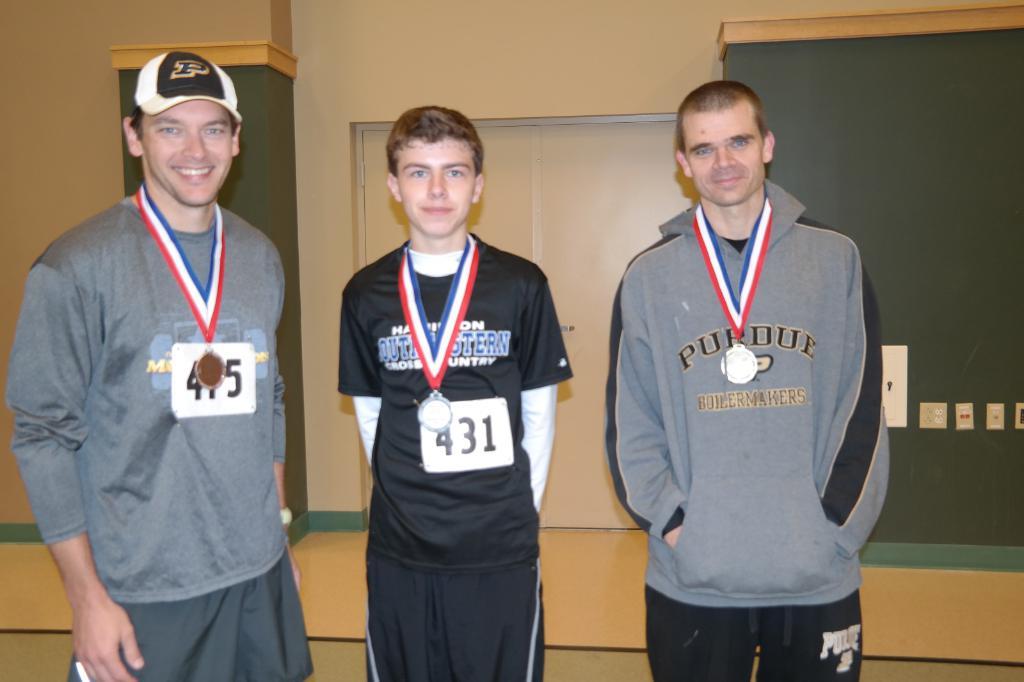What university does the person on the right go to?
Give a very brief answer. Purdue. What is the number of the man in the middle?
Your response must be concise. 431. 